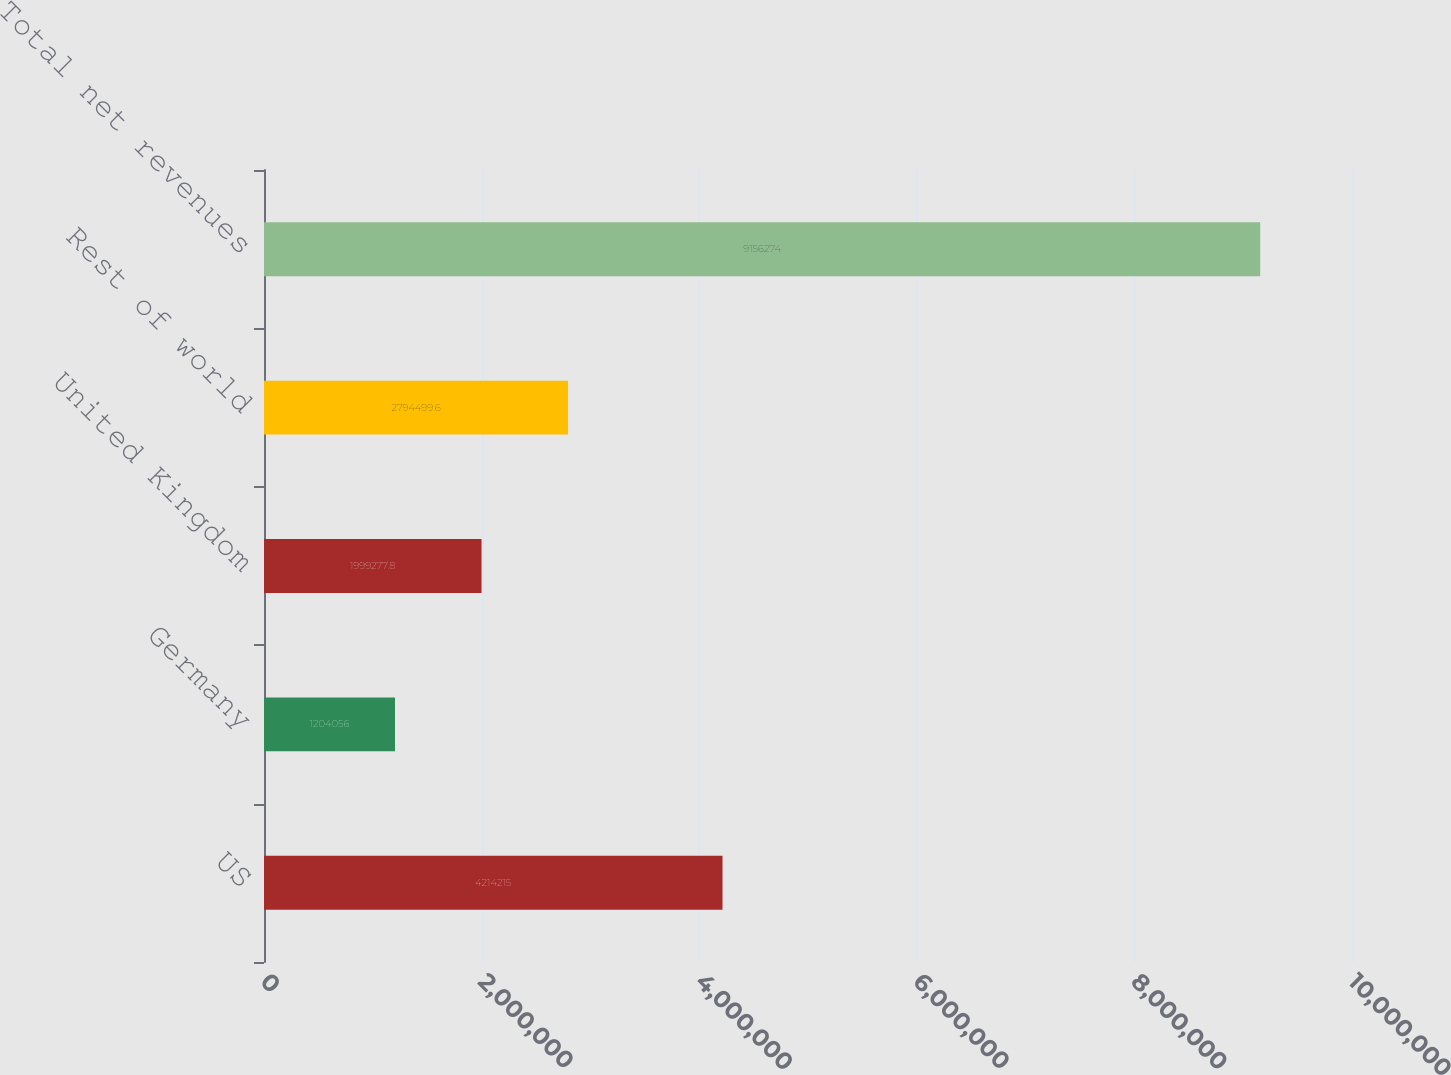<chart> <loc_0><loc_0><loc_500><loc_500><bar_chart><fcel>US<fcel>Germany<fcel>United Kingdom<fcel>Rest of world<fcel>Total net revenues<nl><fcel>4.21422e+06<fcel>1.20406e+06<fcel>1.99928e+06<fcel>2.7945e+06<fcel>9.15627e+06<nl></chart> 